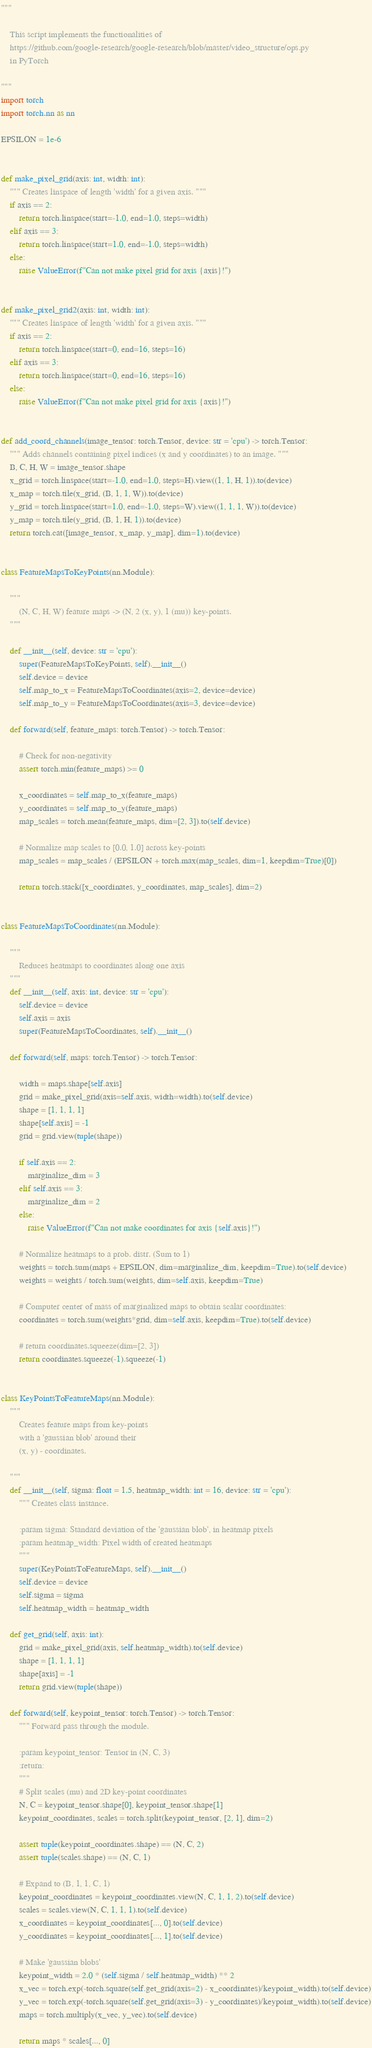Convert code to text. <code><loc_0><loc_0><loc_500><loc_500><_Python_>"""

    This script implements the functionalities of
    https://github.com/google-research/google-research/blob/master/video_structure/ops.py
    in PyTorch

"""
import torch
import torch.nn as nn

EPSILON = 1e-6


def make_pixel_grid(axis: int, width: int):
    """ Creates linspace of length 'width' for a given axis. """
    if axis == 2:
        return torch.linspace(start=-1.0, end=1.0, steps=width)
    elif axis == 3:
        return torch.linspace(start=1.0, end=-1.0, steps=width)
    else:
        raise ValueError(f"Can not make pixel grid for axis {axis}!")


def make_pixel_grid2(axis: int, width: int):
    """ Creates linspace of length 'width' for a given axis. """
    if axis == 2:
        return torch.linspace(start=0, end=16, steps=16)
    elif axis == 3:
        return torch.linspace(start=0, end=16, steps=16)
    else:
        raise ValueError(f"Can not make pixel grid for axis {axis}!")


def add_coord_channels(image_tensor: torch.Tensor, device: str = 'cpu') -> torch.Tensor:
    """ Adds channels containing pixel indices (x and y coordinates) to an image. """
    B, C, H, W = image_tensor.shape
    x_grid = torch.linspace(start=-1.0, end=1.0, steps=H).view((1, 1, H, 1)).to(device)
    x_map = torch.tile(x_grid, (B, 1, 1, W)).to(device)
    y_grid = torch.linspace(start=1.0, end=-1.0, steps=W).view((1, 1, 1, W)).to(device)
    y_map = torch.tile(y_grid, (B, 1, H, 1)).to(device)
    return torch.cat([image_tensor, x_map, y_map], dim=1).to(device)


class FeatureMapsToKeyPoints(nn.Module):

    """
        (N, C, H, W) feature maps -> (N, 2 (x, y), 1 (mu)) key-points.
    """

    def __init__(self, device: str = 'cpu'):
        super(FeatureMapsToKeyPoints, self).__init__()
        self.device = device
        self.map_to_x = FeatureMapsToCoordinates(axis=2, device=device)
        self.map_to_y = FeatureMapsToCoordinates(axis=3, device=device)

    def forward(self, feature_maps: torch.Tensor) -> torch.Tensor:

        # Check for non-negativity
        assert torch.min(feature_maps) >= 0

        x_coordinates = self.map_to_x(feature_maps)
        y_coordinates = self.map_to_y(feature_maps)
        map_scales = torch.mean(feature_maps, dim=[2, 3]).to(self.device)

        # Normalize map scales to [0.0, 1.0] across key-points
        map_scales = map_scales / (EPSILON + torch.max(map_scales, dim=1, keepdim=True)[0])

        return torch.stack([x_coordinates, y_coordinates, map_scales], dim=2)


class FeatureMapsToCoordinates(nn.Module):

    """
        Reduces heatmaps to coordinates along one axis
    """
    def __init__(self, axis: int, device: str = 'cpu'):
        self.device = device
        self.axis = axis
        super(FeatureMapsToCoordinates, self).__init__()

    def forward(self, maps: torch.Tensor) -> torch.Tensor:

        width = maps.shape[self.axis]
        grid = make_pixel_grid(axis=self.axis, width=width).to(self.device)
        shape = [1, 1, 1, 1]
        shape[self.axis] = -1
        grid = grid.view(tuple(shape))

        if self.axis == 2:
            marginalize_dim = 3
        elif self.axis == 3:
            marginalize_dim = 2
        else:
            raise ValueError(f"Can not make coordinates for axis {self.axis}!")

        # Normalize heatmaps to a prob. distr. (Sum to 1)
        weights = torch.sum(maps + EPSILON, dim=marginalize_dim, keepdim=True).to(self.device)
        weights = weights / torch.sum(weights, dim=self.axis, keepdim=True)

        # Computer center of mass of marginalized maps to obtain scalar coordinates:
        coordinates = torch.sum(weights*grid, dim=self.axis, keepdim=True).to(self.device)

        # return coordinates.squeeze(dim=[2, 3])
        return coordinates.squeeze(-1).squeeze(-1)


class KeyPointsToFeatureMaps(nn.Module):
    """
        Creates feature maps from key-points
        with a 'gaussian blob' around their
        (x, y) - coordinates.

    """
    def __init__(self, sigma: float = 1.5, heatmap_width: int = 16, device: str = 'cpu'):
        """ Creates class instance.

        :param sigma: Standard deviation of the 'gaussian blob', in heatmap pixels
        :param heatmap_width: Pixel width of created heatmaps
        """
        super(KeyPointsToFeatureMaps, self).__init__()
        self.device = device
        self.sigma = sigma
        self.heatmap_width = heatmap_width

    def get_grid(self, axis: int):
        grid = make_pixel_grid(axis, self.heatmap_width).to(self.device)
        shape = [1, 1, 1, 1]
        shape[axis] = -1
        return grid.view(tuple(shape))

    def forward(self, keypoint_tensor: torch.Tensor) -> torch.Tensor:
        """ Forward pass through the module.

        :param keypoint_tensor: Tensor in (N, C, 3)
        :return:
        """
        # Split scales (mu) and 2D key-point coordinates
        N, C = keypoint_tensor.shape[0], keypoint_tensor.shape[1]
        keypoint_coordinates, scales = torch.split(keypoint_tensor, [2, 1], dim=2)

        assert tuple(keypoint_coordinates.shape) == (N, C, 2)
        assert tuple(scales.shape) == (N, C, 1)

        # Expand to (B, 1, 1, C, 1)
        keypoint_coordinates = keypoint_coordinates.view(N, C, 1, 1, 2).to(self.device)
        scales = scales.view(N, C, 1, 1, 1).to(self.device)
        x_coordinates = keypoint_coordinates[..., 0].to(self.device)
        y_coordinates = keypoint_coordinates[..., 1].to(self.device)

        # Make 'gaussian blobs'
        keypoint_width = 2.0 * (self.sigma / self.heatmap_width) ** 2
        x_vec = torch.exp(-torch.square(self.get_grid(axis=2) - x_coordinates)/keypoint_width).to(self.device)
        y_vec = torch.exp(-torch.square(self.get_grid(axis=3) - y_coordinates)/keypoint_width).to(self.device)
        maps = torch.multiply(x_vec, y_vec).to(self.device)

        return maps * scales[..., 0]




</code> 